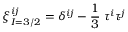<formula> <loc_0><loc_0><loc_500><loc_500>\xi _ { I = 3 / 2 } ^ { i j } = \delta ^ { i j } - \frac { 1 } { 3 } \, \tau ^ { i } \tau ^ { j }</formula> 